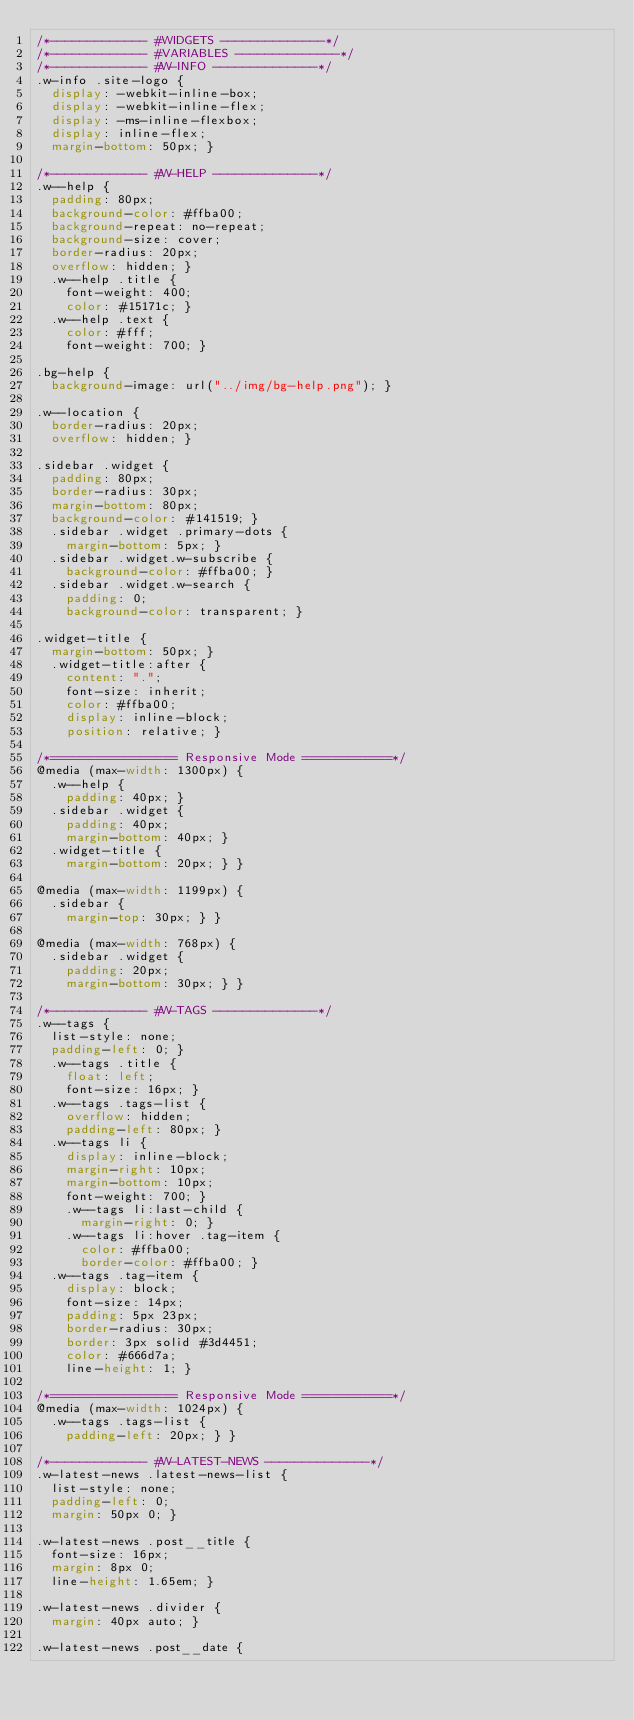Convert code to text. <code><loc_0><loc_0><loc_500><loc_500><_CSS_>/*------------- #WIDGETS --------------*/
/*------------- #VARIABLES --------------*/
/*------------- #W-INFO --------------*/
.w-info .site-logo {
  display: -webkit-inline-box;
  display: -webkit-inline-flex;
  display: -ms-inline-flexbox;
  display: inline-flex;
  margin-bottom: 50px; }

/*------------- #W-HELP --------------*/
.w--help {
  padding: 80px;
  background-color: #ffba00;
  background-repeat: no-repeat;
  background-size: cover;
  border-radius: 20px;
  overflow: hidden; }
  .w--help .title {
    font-weight: 400;
    color: #15171c; }
  .w--help .text {
    color: #fff;
    font-weight: 700; }

.bg-help {
  background-image: url("../img/bg-help.png"); }

.w--location {
  border-radius: 20px;
  overflow: hidden; }

.sidebar .widget {
  padding: 80px;
  border-radius: 30px;
  margin-bottom: 80px;
  background-color: #141519; }
  .sidebar .widget .primary-dots {
    margin-bottom: 5px; }
  .sidebar .widget.w-subscribe {
    background-color: #ffba00; }
  .sidebar .widget.w-search {
    padding: 0;
    background-color: transparent; }

.widget-title {
  margin-bottom: 50px; }
  .widget-title:after {
    content: ".";
    font-size: inherit;
    color: #ffba00;
    display: inline-block;
    position: relative; }

/*================= Responsive Mode ============*/
@media (max-width: 1300px) {
  .w--help {
    padding: 40px; }
  .sidebar .widget {
    padding: 40px;
    margin-bottom: 40px; }
  .widget-title {
    margin-bottom: 20px; } }

@media (max-width: 1199px) {
  .sidebar {
    margin-top: 30px; } }

@media (max-width: 768px) {
  .sidebar .widget {
    padding: 20px;
    margin-bottom: 30px; } }

/*------------- #W-TAGS --------------*/
.w--tags {
  list-style: none;
  padding-left: 0; }
  .w--tags .title {
    float: left;
    font-size: 16px; }
  .w--tags .tags-list {
    overflow: hidden;
    padding-left: 80px; }
  .w--tags li {
    display: inline-block;
    margin-right: 10px;
    margin-bottom: 10px;
    font-weight: 700; }
    .w--tags li:last-child {
      margin-right: 0; }
    .w--tags li:hover .tag-item {
      color: #ffba00;
      border-color: #ffba00; }
  .w--tags .tag-item {
    display: block;
    font-size: 14px;
    padding: 5px 23px;
    border-radius: 30px;
    border: 3px solid #3d4451;
    color: #666d7a;
    line-height: 1; }

/*================= Responsive Mode ============*/
@media (max-width: 1024px) {
  .w--tags .tags-list {
    padding-left: 20px; } }

/*------------- #W-LATEST-NEWS --------------*/
.w-latest-news .latest-news-list {
  list-style: none;
  padding-left: 0;
  margin: 50px 0; }

.w-latest-news .post__title {
  font-size: 16px;
  margin: 8px 0;
  line-height: 1.65em; }

.w-latest-news .divider {
  margin: 40px auto; }

.w-latest-news .post__date {</code> 